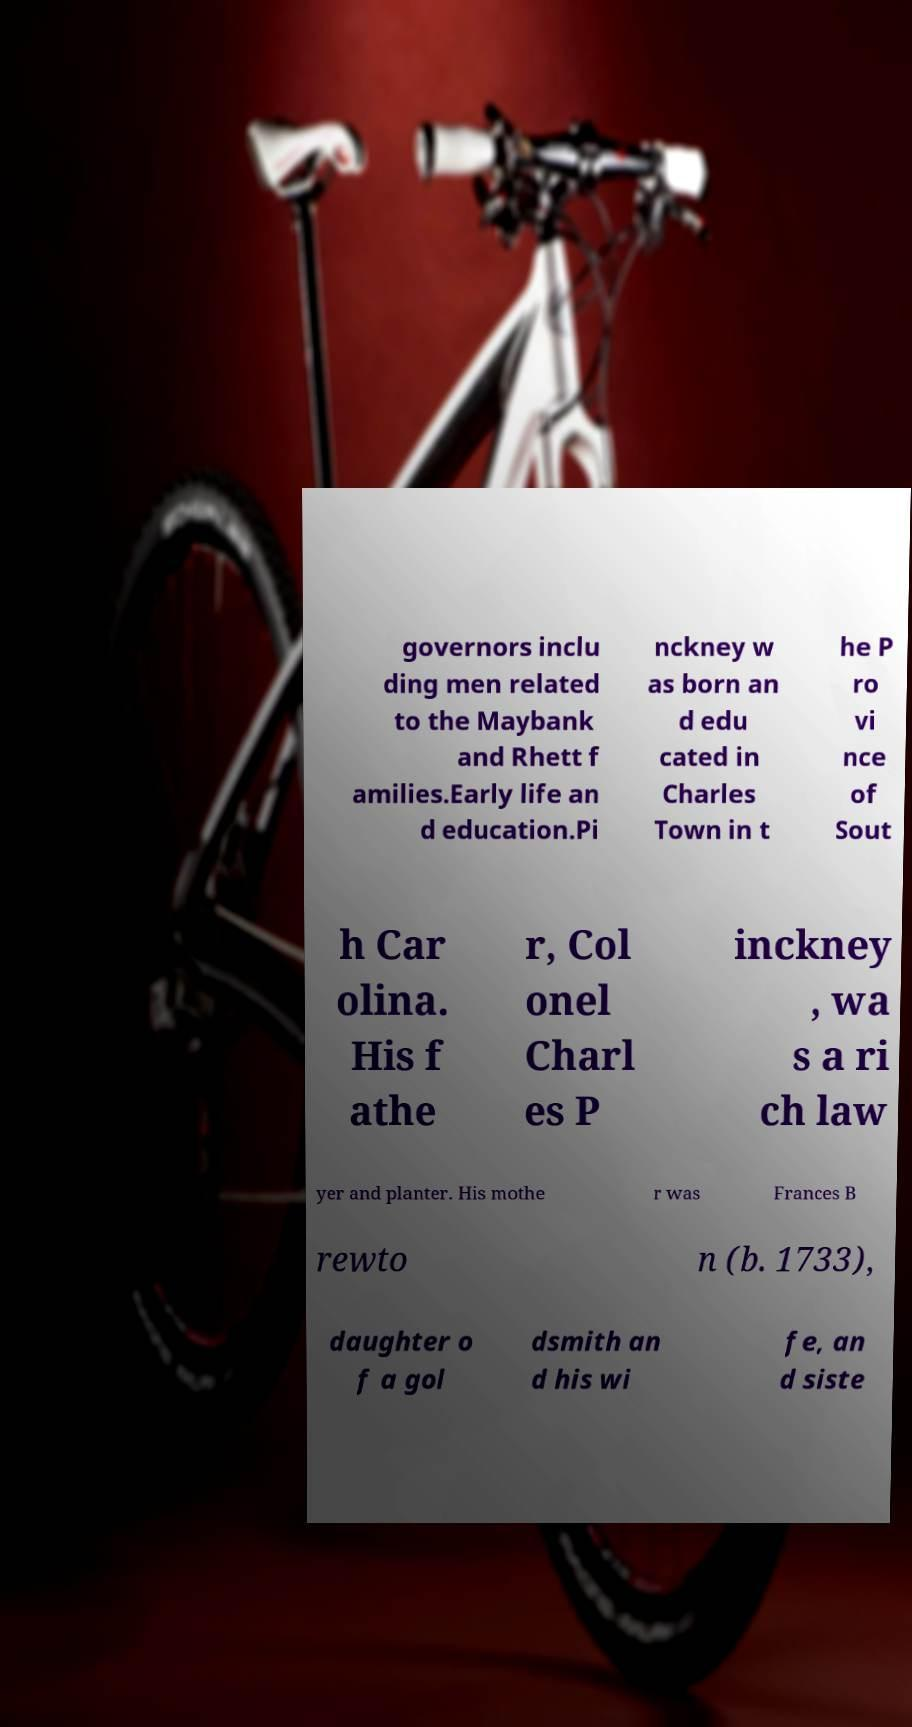Can you read and provide the text displayed in the image?This photo seems to have some interesting text. Can you extract and type it out for me? governors inclu ding men related to the Maybank and Rhett f amilies.Early life an d education.Pi nckney w as born an d edu cated in Charles Town in t he P ro vi nce of Sout h Car olina. His f athe r, Col onel Charl es P inckney , wa s a ri ch law yer and planter. His mothe r was Frances B rewto n (b. 1733), daughter o f a gol dsmith an d his wi fe, an d siste 